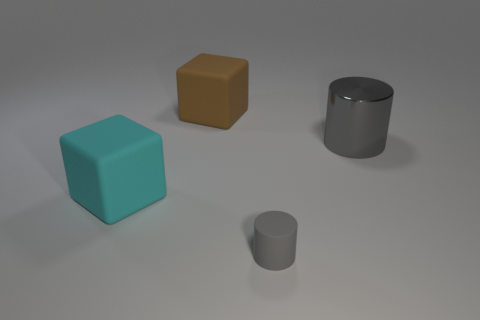What number of other things are the same color as the tiny thing?
Your answer should be very brief. 1. Is there anything else that has the same shape as the big shiny thing?
Provide a succinct answer. Yes. How many large rubber things are on the left side of the big brown object?
Offer a terse response. 1. Is there a brown rubber cube?
Keep it short and to the point. Yes. There is a object that is to the right of the cylinder that is in front of the big matte thing in front of the large brown rubber cube; what is its color?
Keep it short and to the point. Gray. There is a large cube behind the cyan rubber thing; is there a rubber cube that is to the right of it?
Your answer should be compact. No. There is a big thing right of the brown rubber block; is its color the same as the big matte cube to the left of the big brown rubber object?
Keep it short and to the point. No. How many cyan cubes are the same size as the gray metallic cylinder?
Your response must be concise. 1. Does the thing in front of the cyan thing have the same size as the big gray metal thing?
Offer a terse response. No. The big gray object is what shape?
Provide a short and direct response. Cylinder. 